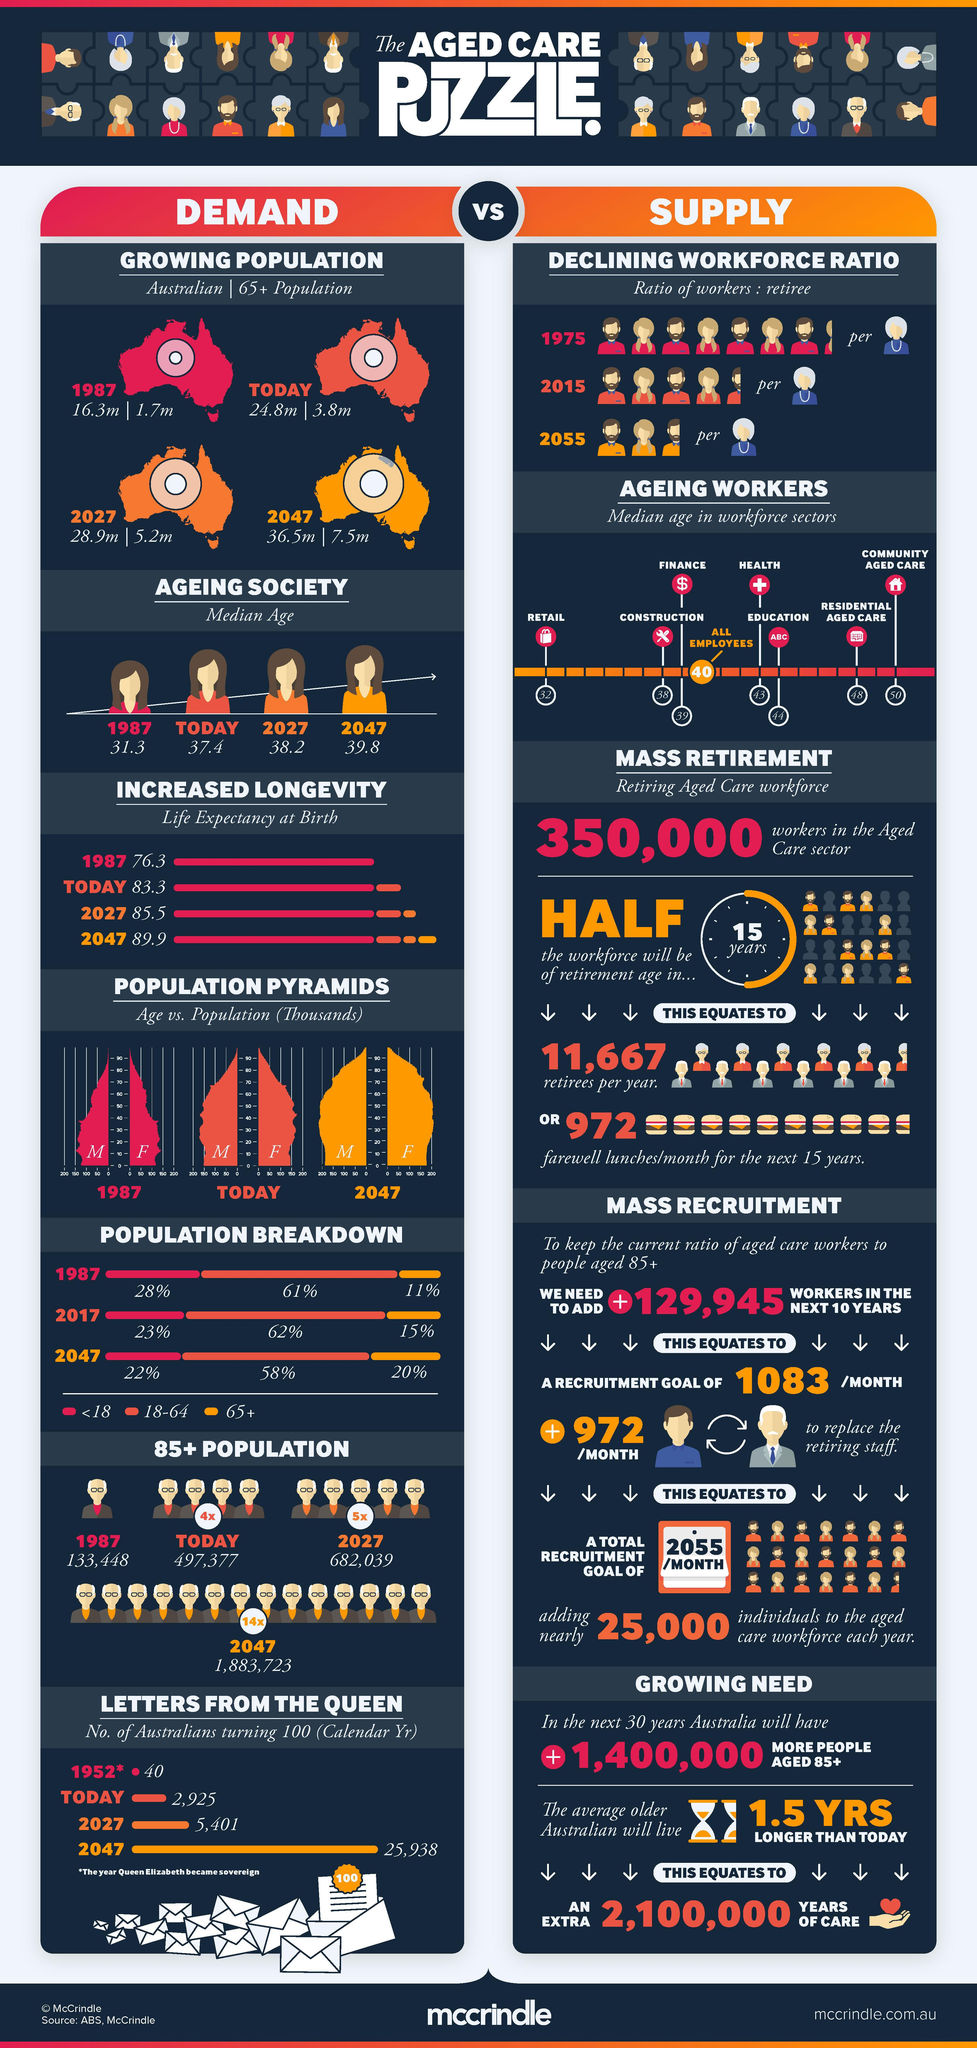Identify some key points in this picture. In 1987, approximately 11% of the Australian population was aged 65 years or older. In 1987, the population of Australians aged 65 and older was approximately 1.7 million. The median age of the workforce in the retail sector is 32. The estimated population of Australians by 2047 is expected to be 36.5 million. In 2017, 62% of Australians in the age group of 18-64 years were present. 